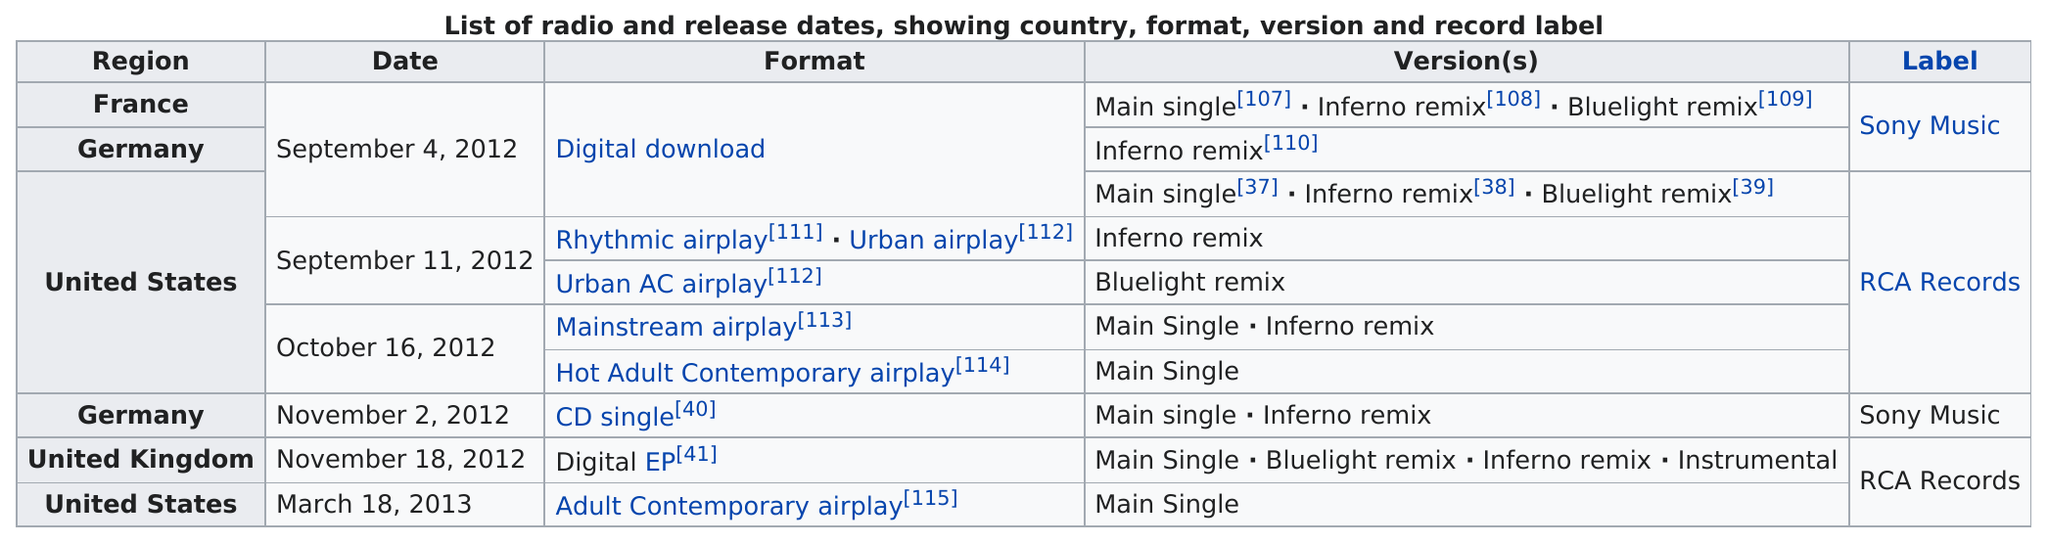Highlight a few significant elements in this photo. France had a release with the same label as Germany. The United Kingdom did not have the Sony Music label. The United Kingdom released "Where was it released first, United Kingdom or Germany?" in Germany. There are six dates listed on this table. It was 7 days after the song was released in France that it was released in the United States. 